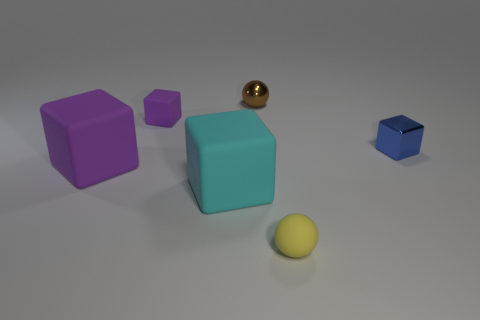Add 1 purple things. How many objects exist? 7 Subtract all cubes. How many objects are left? 2 Subtract 1 brown spheres. How many objects are left? 5 Subtract all tiny blue shiny things. Subtract all large blocks. How many objects are left? 3 Add 2 cyan cubes. How many cyan cubes are left? 3 Add 4 small cubes. How many small cubes exist? 6 